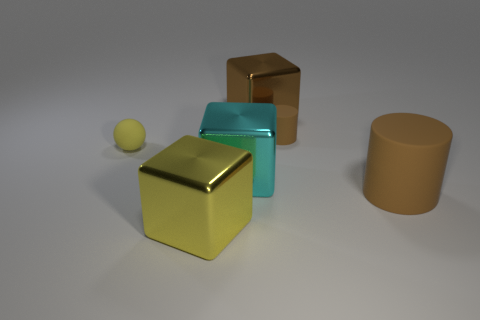Subtract all gray blocks. Subtract all brown cylinders. How many blocks are left? 3 Add 3 tiny green cylinders. How many objects exist? 9 Subtract all cylinders. How many objects are left? 4 Add 4 tiny brown rubber objects. How many tiny brown rubber objects exist? 5 Subtract 0 purple blocks. How many objects are left? 6 Subtract all small red rubber cylinders. Subtract all metallic things. How many objects are left? 3 Add 2 large matte cylinders. How many large matte cylinders are left? 3 